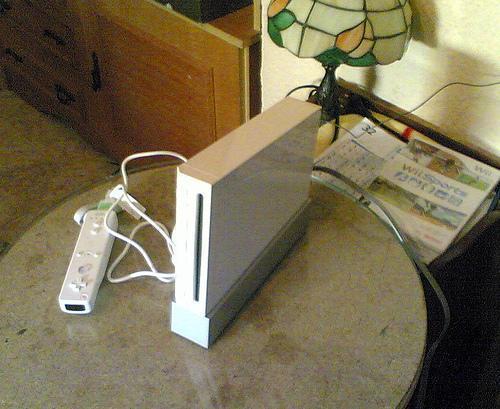How many WIIs are shown?
Give a very brief answer. 1. 